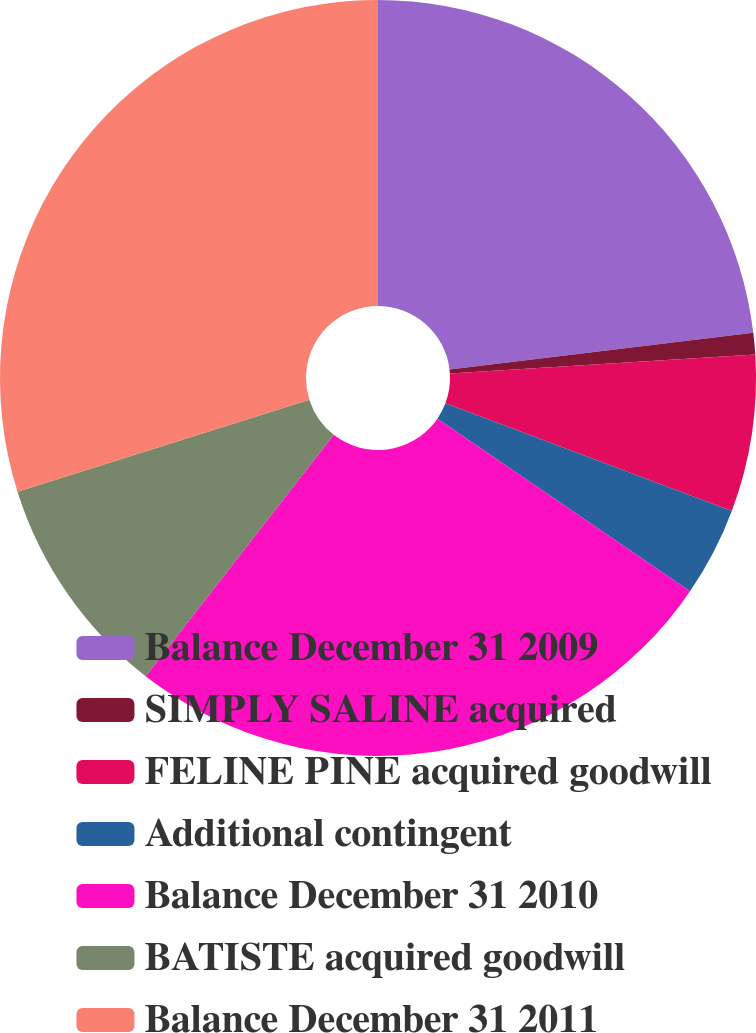<chart> <loc_0><loc_0><loc_500><loc_500><pie_chart><fcel>Balance December 31 2009<fcel>SIMPLY SALINE acquired<fcel>FELINE PINE acquired goodwill<fcel>Additional contingent<fcel>Balance December 31 2010<fcel>BATISTE acquired goodwill<fcel>Balance December 31 2011<nl><fcel>23.09%<fcel>0.92%<fcel>6.71%<fcel>3.82%<fcel>25.99%<fcel>9.6%<fcel>29.86%<nl></chart> 